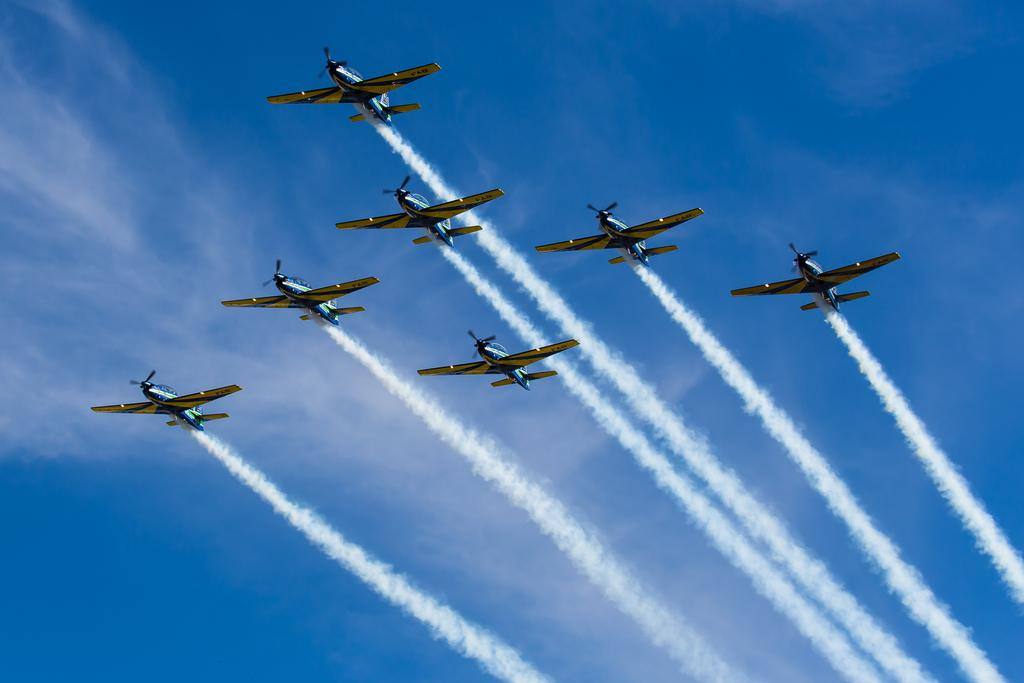What event is taking place in the image? There is an aircraft show in the image. What is the aircraft doing during the show? The aircraft is leaving smoke in the lines. What can be seen in the background of the image? The sky is visible in the background of the image. What is the color of the sky in the image? The sky is blue in color. Can you see any baseball players in the image? There are no baseball players present in the image; it features an aircraft show. Is there a haircut being given to someone in the image? There is no haircut being given in the image; it features an aircraft show. 